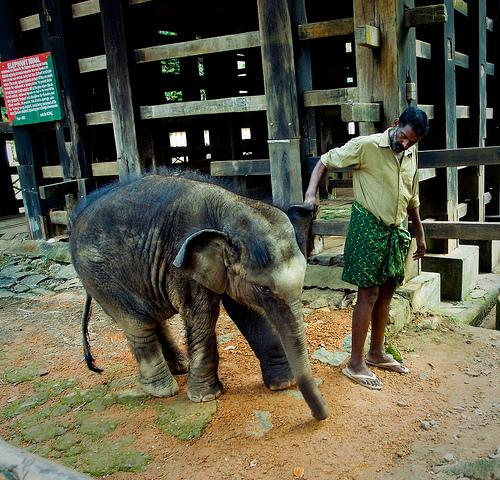Question: how many elephants are visible?
Choices:
A. 2.
B. 1.
C. 3.
D. 4.
Answer with the letter. Answer: B Question: where is th man grabbing the elelphant?
Choices:
A. Trunk.
B. Tail.
C. Ear.
D. Head.
Answer with the letter. Answer: C Question: what color bottoms is the man wearing?
Choices:
A. Tan.
B. Khaki.
C. Rouge.
D. Green.
Answer with the letter. Answer: D Question: what kind of shoes are visible?
Choices:
A. Tennis shoes.
B. Wing tips.
C. Deck shoes.
D. Flip flops.
Answer with the letter. Answer: D 